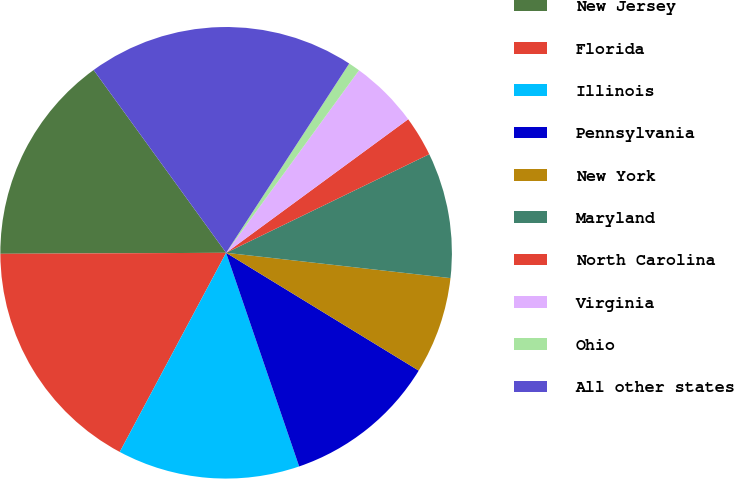<chart> <loc_0><loc_0><loc_500><loc_500><pie_chart><fcel>New Jersey<fcel>Florida<fcel>Illinois<fcel>Pennsylvania<fcel>New York<fcel>Maryland<fcel>North Carolina<fcel>Virginia<fcel>Ohio<fcel>All other states<nl><fcel>15.09%<fcel>17.12%<fcel>13.05%<fcel>11.02%<fcel>6.95%<fcel>8.98%<fcel>2.88%<fcel>4.91%<fcel>0.84%<fcel>19.16%<nl></chart> 